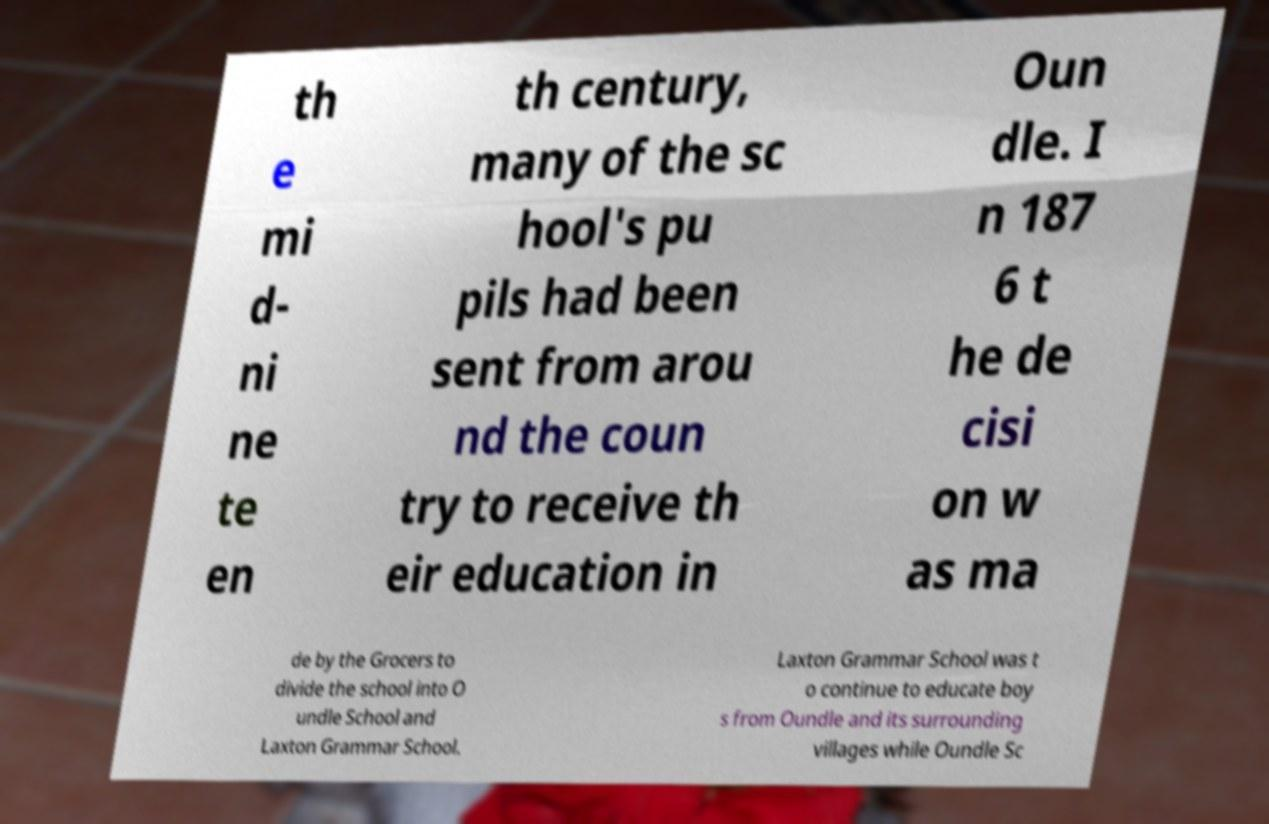Could you assist in decoding the text presented in this image and type it out clearly? th e mi d- ni ne te en th century, many of the sc hool's pu pils had been sent from arou nd the coun try to receive th eir education in Oun dle. I n 187 6 t he de cisi on w as ma de by the Grocers to divide the school into O undle School and Laxton Grammar School. Laxton Grammar School was t o continue to educate boy s from Oundle and its surrounding villages while Oundle Sc 